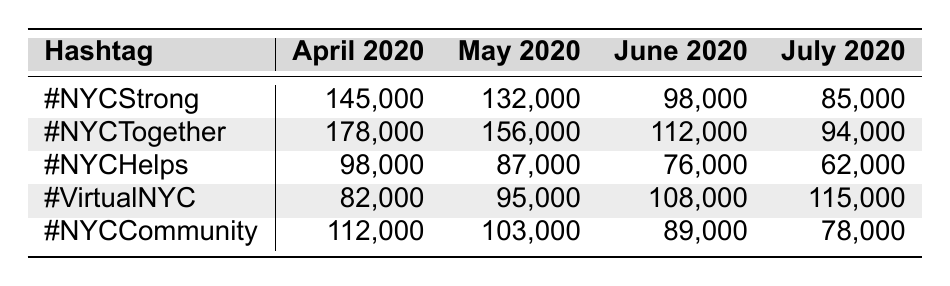What was the engagement for the hashtag #NYCStrong in May 2020? The table shows that the engagement for the hashtag #NYCStrong in May 2020 is 132,000.
Answer: 132,000 Which hashtag had the highest engagement in April 2020? By comparing the values in the April 2020 column, #NYCTogether had the highest engagement at 178,000.
Answer: #NYCTogether What was the change in engagement for #VirtualNYC from April 2020 to July 2020? The engagement for #VirtualNYC in April 2020 was 82,000 and in July 2020 was 115,000. The change is 115,000 - 82,000 = 33,000.
Answer: 33,000 Which month had the lowest overall engagement across all hashtags? To find this, we compare totals: April = 145,000 + 178,000 + 98,000 + 82,000 + 112,000 = 615,000; May = 132,000 + 156,000 + 87,000 + 95,000 + 103,000 = 573,000; June = 98,000 + 112,000 + 76,000 + 108,000 + 89,000 = 483,000; July = 85,000 + 94,000 + 62,000 + 115,000 + 78,000 = 434,000. The lowest overall is July with 434,000.
Answer: July 2020 Which hashtag showed the most significant decline from April to July? For each hashtag, we calculate the difference between April and July: #NYCStrong: 145,000 - 85,000 = 60,000; #NYCTogether: 178,000 - 94,000 = 84,000; #NYCHelps: 98,000 - 62,000 = 36,000; #VirtualNYC: 82,000 - 115,000 = -33,000 (increase); #NYCCommunity: 112,000 - 78,000 = 34,000. #NYCTogether had the largest decline of 84,000.
Answer: #NYCTogether Is it true that #NYCHelps had a decline in engagement every month from April to July? Checking the values for #NYCHelps, we see: April 98,000, May 87,000, June 76,000, July 62,000; each month shows a decline.
Answer: Yes What was the average engagement for #NYCCommunity over the four months? The total engagement for #NYCCommunity is 112,000 + 103,000 + 89,000 + 78,000 = 382,000. To find the average, divide by the number of months: 382,000 / 4 = 95,500.
Answer: 95,500 In which month did #VirtualNYC reach its peak engagement? Looking at the values for #VirtualNYC: April 82,000, May 95,000, June 108,000, July 115,000. The highest value is 115,000 in July.
Answer: July 2020 How do the total engagements in June compare to those in May? May total is 573,000, June total is 483,000. By subtracting: 573,000 - 483,000 = 90,000, indicating that June had 90,000 less engagement than May.
Answer: June had 90,000 less engagement than May 